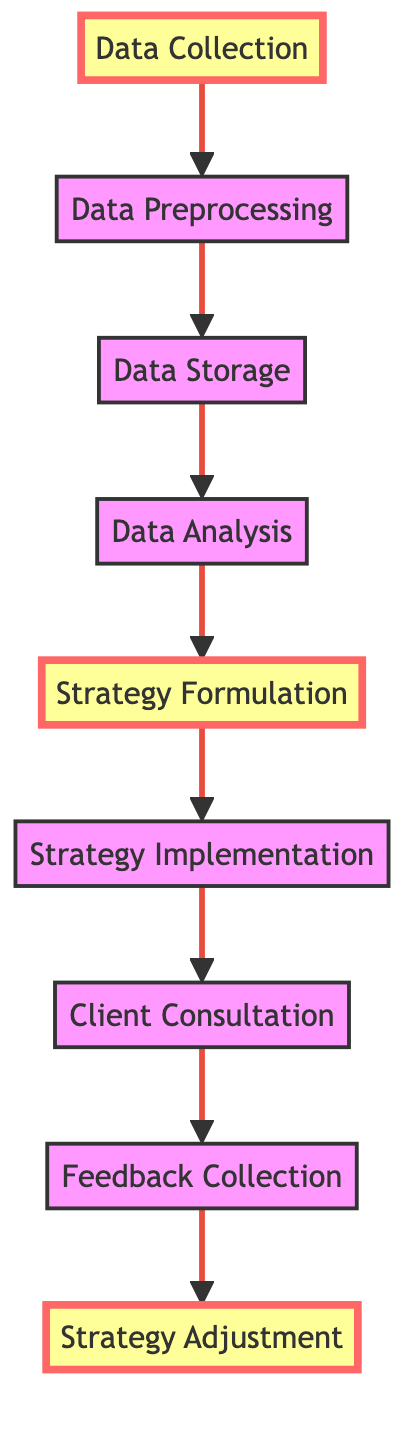What is the first step in the process? The first step in the process is indicated at the bottom of the flowchart, which is "Data Collection."
Answer: Data Collection How many nodes are in the flowchart? By counting all the distinct steps in the flowchart from "Data Collection" to "Strategy Adjustment," there are a total of nine nodes.
Answer: Nine What is the last step in the process? The last step, shown at the top of the flowchart, is "Strategy Adjustment."
Answer: Strategy Adjustment Which node follows "Data Analysis"? "Strategy Formulation" directly follows "Data Analysis," as indicated by the upward arrow connecting the two nodes.
Answer: Strategy Formulation How many edges connect "Client Consultation" and "Feedback Collection"? There is one edge (arrow) that connects "Client Consultation" to "Feedback Collection," indicating a direct flow of information.
Answer: One What are the highlighted nodes in the diagram? The highlighted nodes represent important stages, which are "Data Collection," "Strategy Formulation," and "Strategy Adjustment."
Answer: Data Collection, Strategy Formulation, Strategy Adjustment What is the relationship between "Strategy Implementation" and "Client Consultation"? "Strategy Implementation" proceeds to "Client Consultation," showing that the strategies developed are discussed with clients after execution.
Answer: Sequential Which process comes immediately after "Feedback Collection"? The process that comes immediately after "Feedback Collection" is "Strategy Adjustment," indicating the response to client feedback.
Answer: Strategy Adjustment 